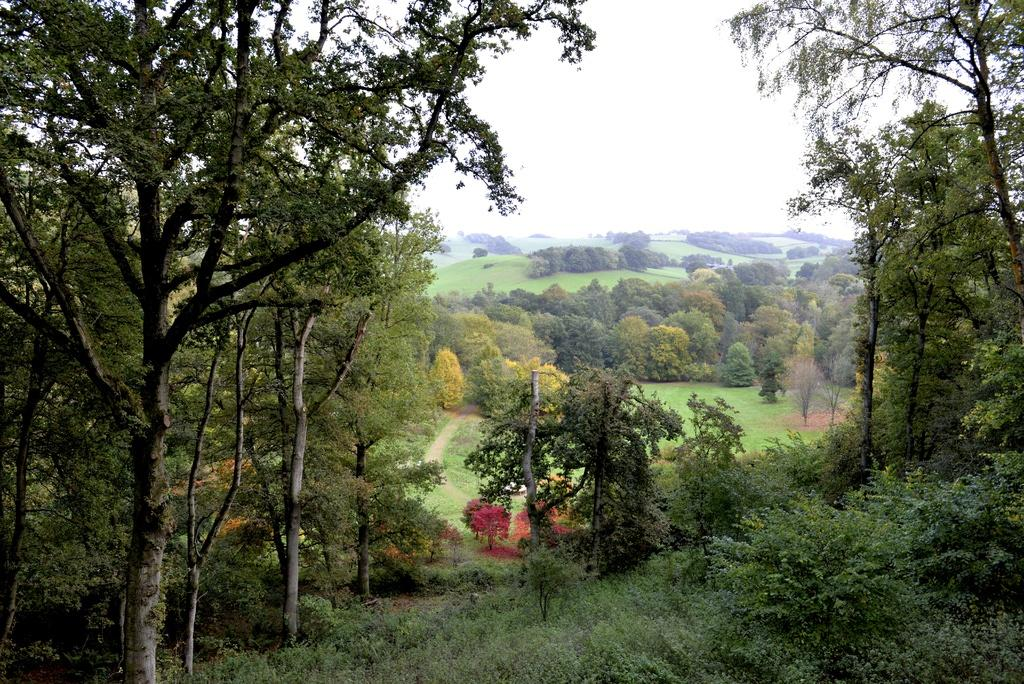What type of vegetation can be seen on both sides of the picture? There are trees on either side of the picture. Can you describe the background of the picture? There are trees in the background of the picture. What is visible at the top of the picture? The sky is visible at the top of the picture. Where might this image have been taken? The image might have been taken in a forest area, given the presence of trees. What is the queen's role in the image? There is no queen present in the image, so it is not possible to determine her role. 